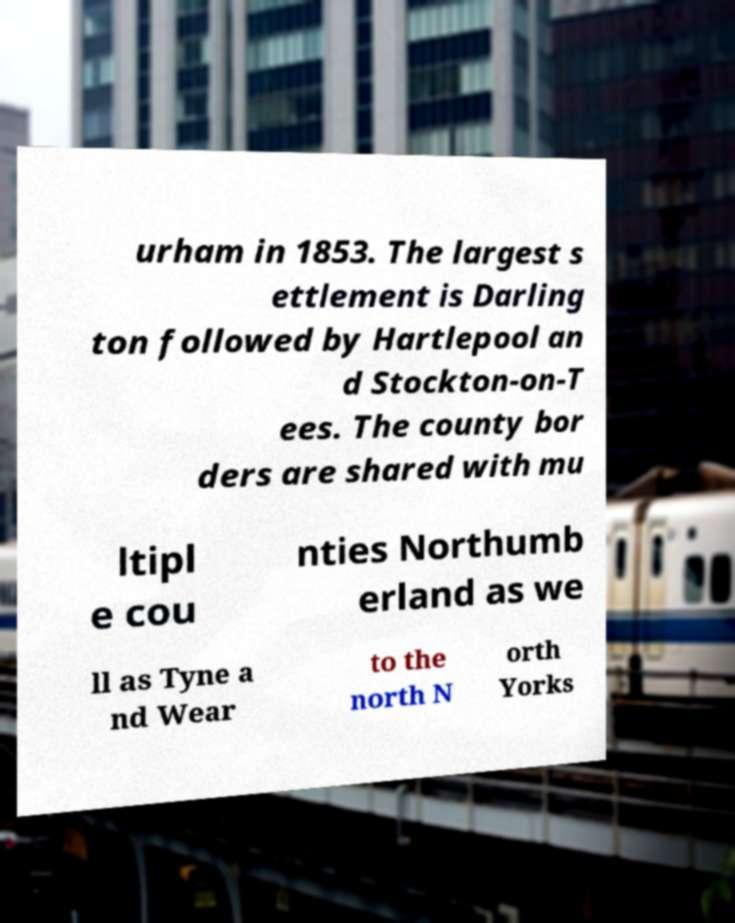For documentation purposes, I need the text within this image transcribed. Could you provide that? urham in 1853. The largest s ettlement is Darling ton followed by Hartlepool an d Stockton-on-T ees. The county bor ders are shared with mu ltipl e cou nties Northumb erland as we ll as Tyne a nd Wear to the north N orth Yorks 